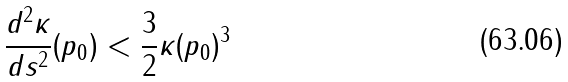<formula> <loc_0><loc_0><loc_500><loc_500>\frac { d ^ { 2 } \kappa } { d s ^ { 2 } } ( p _ { 0 } ) < \frac { 3 } { 2 } \kappa ( p _ { 0 } ) ^ { 3 }</formula> 